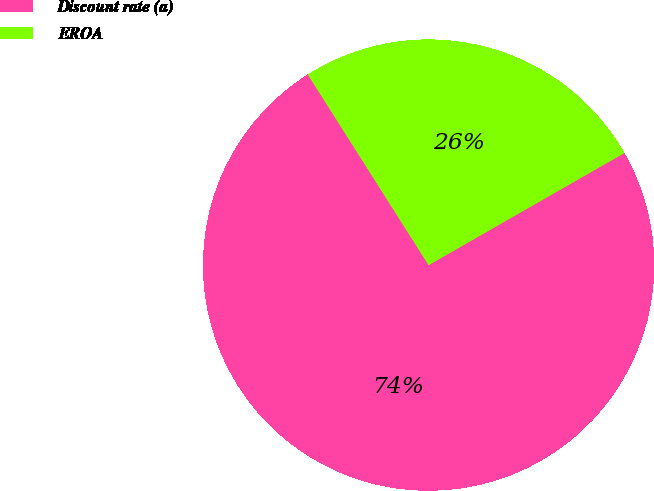<chart> <loc_0><loc_0><loc_500><loc_500><pie_chart><fcel>Discount rate (a)<fcel>EROA<nl><fcel>74.29%<fcel>25.71%<nl></chart> 